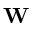Convert formula to latex. <formula><loc_0><loc_0><loc_500><loc_500>W</formula> 